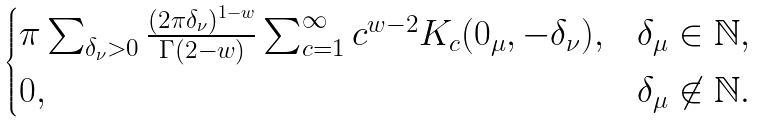Convert formula to latex. <formula><loc_0><loc_0><loc_500><loc_500>\begin{cases} \pi \sum _ { \delta _ { \nu } > 0 } \frac { ( 2 \pi \delta _ { \nu } ) ^ { 1 - w } } { \Gamma ( 2 - w ) } \sum _ { c = 1 } ^ { \infty } c ^ { w - 2 } K _ { c } ( 0 _ { \mu } , - \delta _ { \nu } ) , & \delta _ { \mu } \in \mathbb { N } , \\ 0 , & \delta _ { \mu } \not \in \mathbb { N } . \\ \end{cases}</formula> 